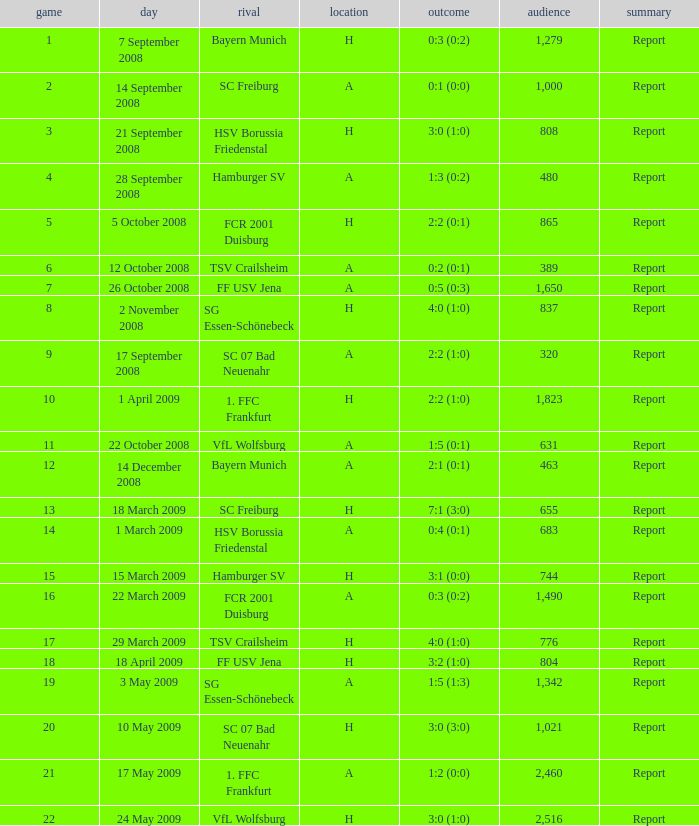What is the match number that had a result of 0:5 (0:3)? 1.0. 